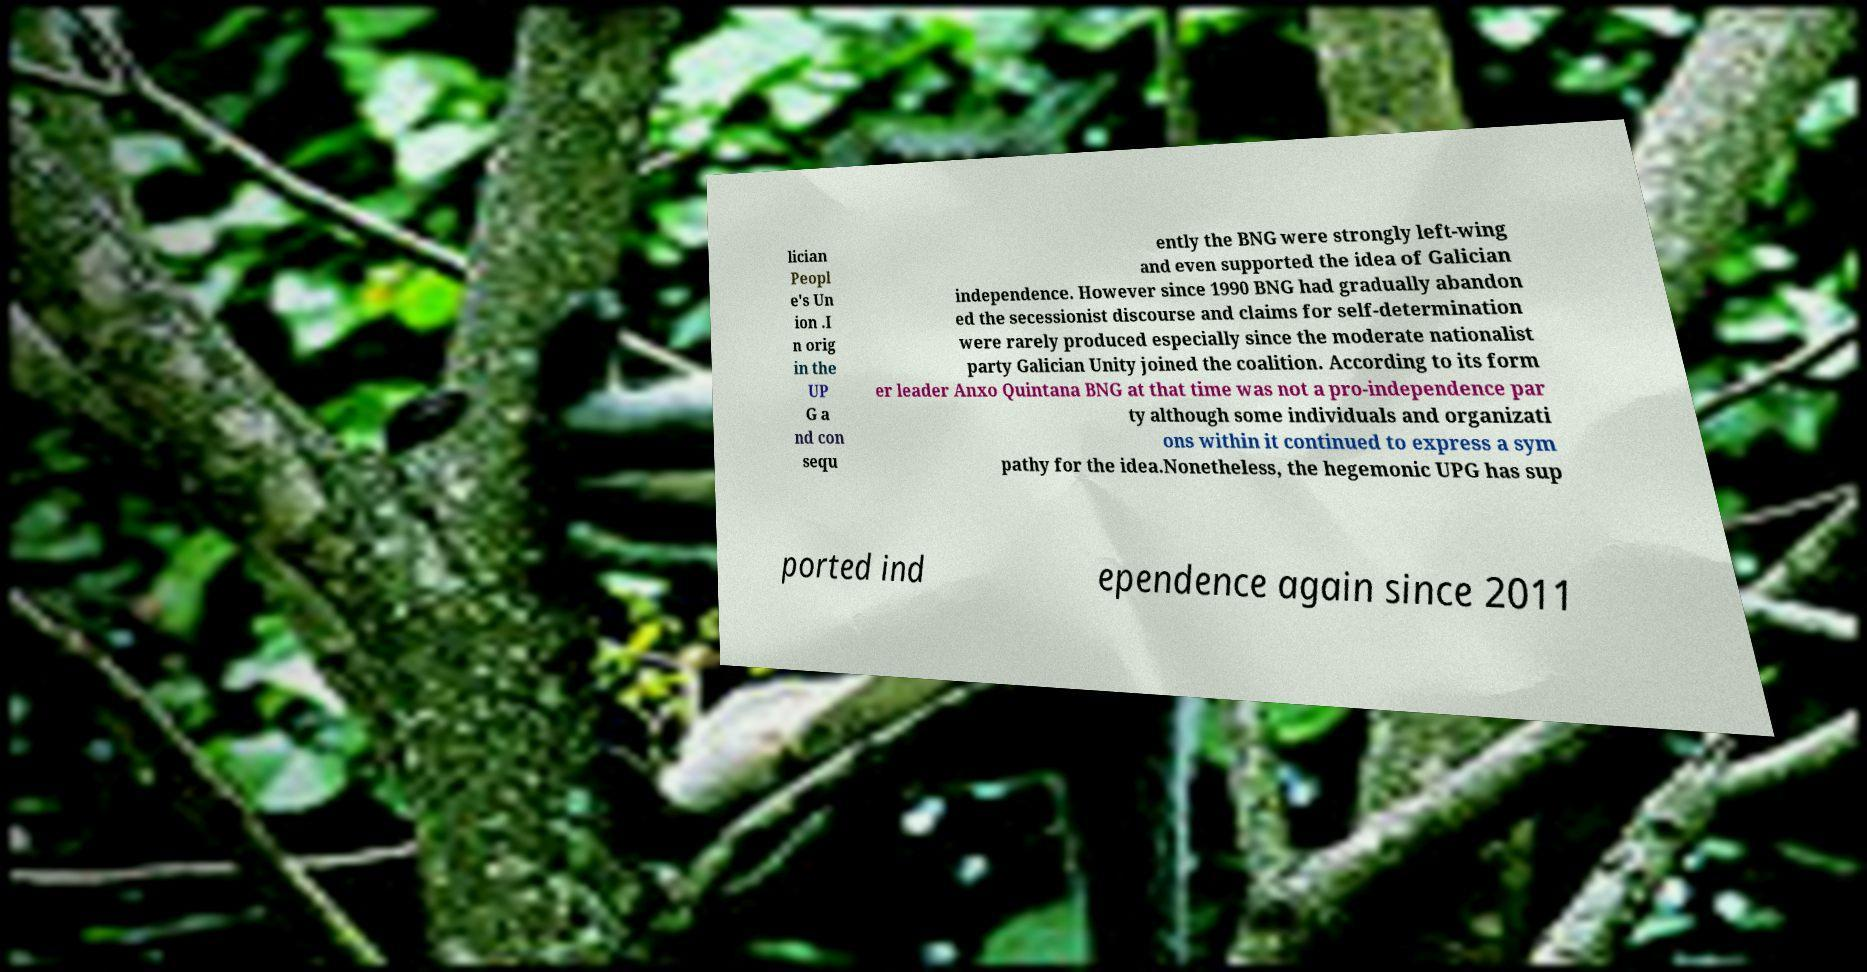Can you read and provide the text displayed in the image?This photo seems to have some interesting text. Can you extract and type it out for me? lician Peopl e's Un ion .I n orig in the UP G a nd con sequ ently the BNG were strongly left-wing and even supported the idea of Galician independence. However since 1990 BNG had gradually abandon ed the secessionist discourse and claims for self-determination were rarely produced especially since the moderate nationalist party Galician Unity joined the coalition. According to its form er leader Anxo Quintana BNG at that time was not a pro-independence par ty although some individuals and organizati ons within it continued to express a sym pathy for the idea.Nonetheless, the hegemonic UPG has sup ported ind ependence again since 2011 